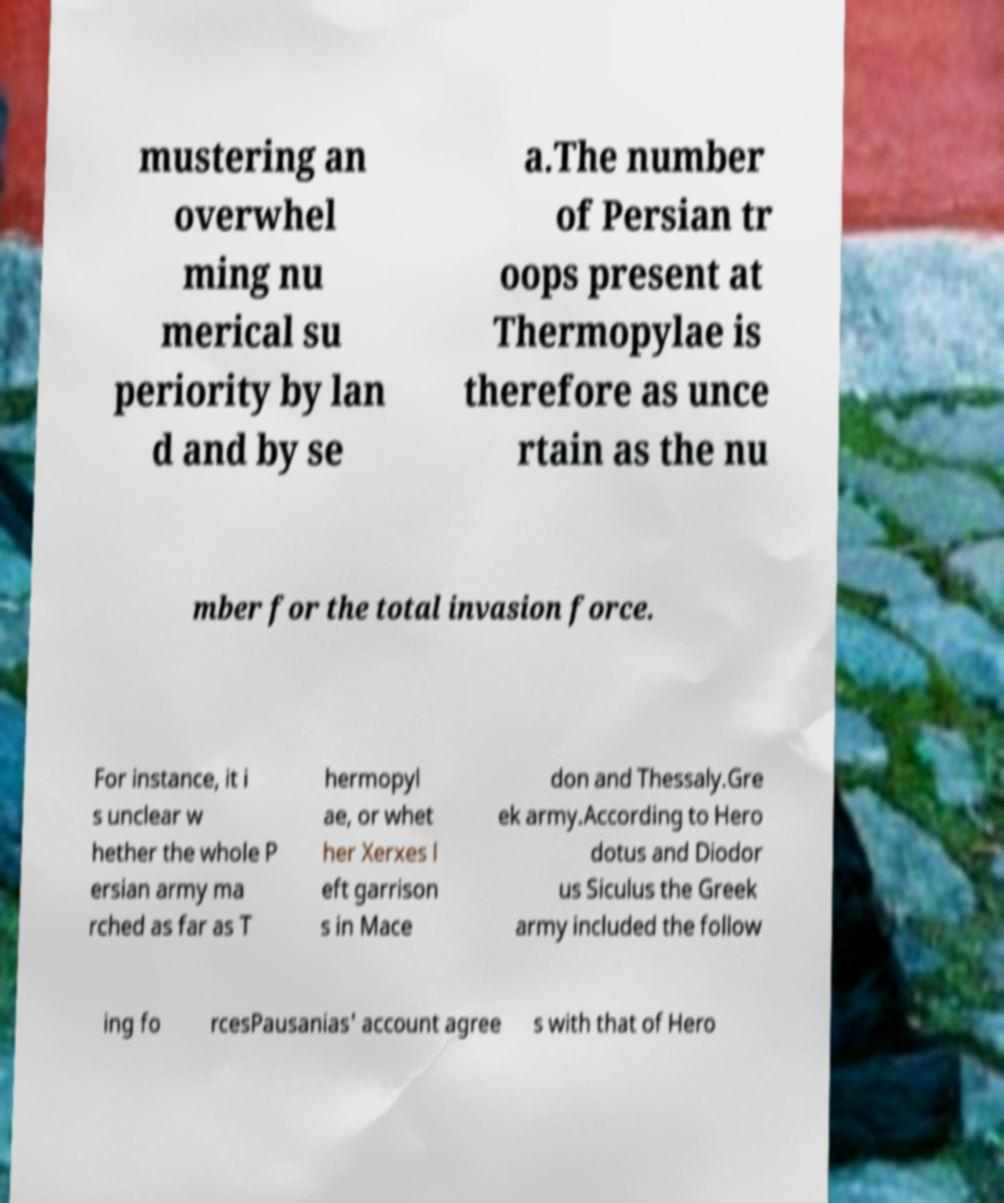Can you read and provide the text displayed in the image?This photo seems to have some interesting text. Can you extract and type it out for me? mustering an overwhel ming nu merical su periority by lan d and by se a.The number of Persian tr oops present at Thermopylae is therefore as unce rtain as the nu mber for the total invasion force. For instance, it i s unclear w hether the whole P ersian army ma rched as far as T hermopyl ae, or whet her Xerxes l eft garrison s in Mace don and Thessaly.Gre ek army.According to Hero dotus and Diodor us Siculus the Greek army included the follow ing fo rcesPausanias' account agree s with that of Hero 